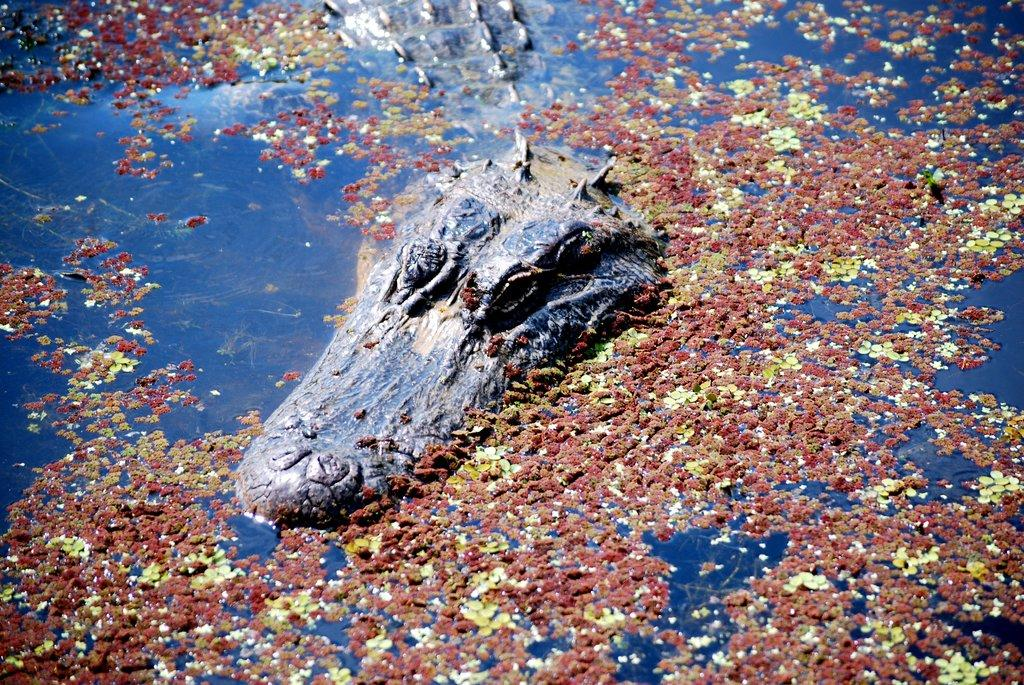What animal can be seen in the water in the image? There is an alligator in the water in the image. What else can be seen on the water's surface? There is an object floating on the water. What type of grain can be seen growing near the alligator in the image? There is no grain visible in the image; it features an alligator in the water and an object floating on the water. 